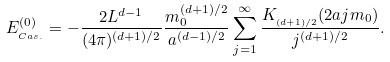Convert formula to latex. <formula><loc_0><loc_0><loc_500><loc_500>E ^ { ( 0 ) } _ { _ { C a s . } } = - \frac { 2 L ^ { d - 1 } } { ( 4 \pi ) ^ { ( d + 1 ) / 2 } } \frac { m _ { 0 } ^ { ( d + 1 ) / 2 } } { a ^ { ( d - 1 ) / 2 } } \sum ^ { \infty } _ { j = 1 } \frac { K _ { _ { ( d + 1 ) / 2 } } ( 2 a j m _ { 0 } ) } { j ^ { ( d + 1 ) / 2 } } .</formula> 